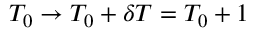Convert formula to latex. <formula><loc_0><loc_0><loc_500><loc_500>T _ { 0 } \rightarrow T _ { 0 } + \delta T = T _ { 0 } + 1</formula> 